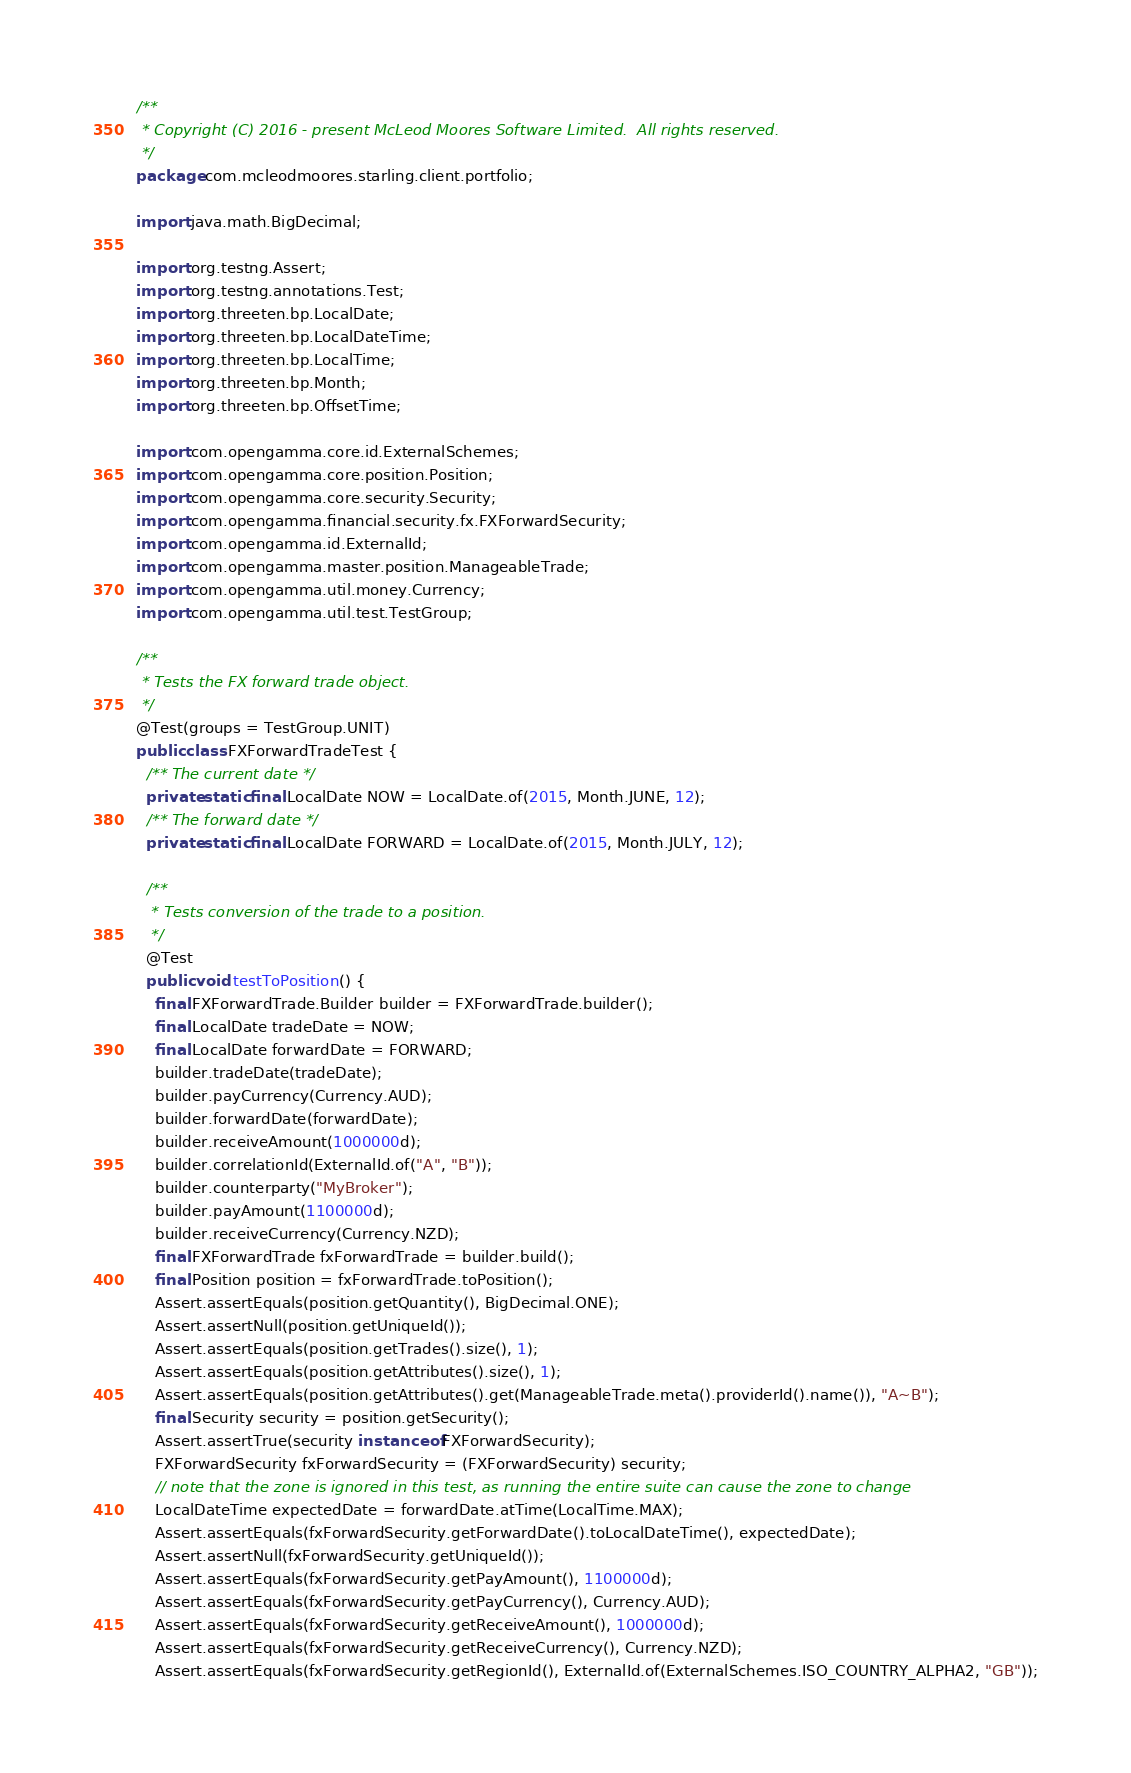<code> <loc_0><loc_0><loc_500><loc_500><_Java_>/**
 * Copyright (C) 2016 - present McLeod Moores Software Limited.  All rights reserved.
 */
package com.mcleodmoores.starling.client.portfolio;

import java.math.BigDecimal;

import org.testng.Assert;
import org.testng.annotations.Test;
import org.threeten.bp.LocalDate;
import org.threeten.bp.LocalDateTime;
import org.threeten.bp.LocalTime;
import org.threeten.bp.Month;
import org.threeten.bp.OffsetTime;

import com.opengamma.core.id.ExternalSchemes;
import com.opengamma.core.position.Position;
import com.opengamma.core.security.Security;
import com.opengamma.financial.security.fx.FXForwardSecurity;
import com.opengamma.id.ExternalId;
import com.opengamma.master.position.ManageableTrade;
import com.opengamma.util.money.Currency;
import com.opengamma.util.test.TestGroup;

/**
 * Tests the FX forward trade object.
 */
@Test(groups = TestGroup.UNIT)
public class FXForwardTradeTest {
  /** The current date */
  private static final LocalDate NOW = LocalDate.of(2015, Month.JUNE, 12);
  /** The forward date */
  private static final LocalDate FORWARD = LocalDate.of(2015, Month.JULY, 12);

  /**
   * Tests conversion of the trade to a position.
   */
  @Test
  public void testToPosition() {
    final FXForwardTrade.Builder builder = FXForwardTrade.builder();
    final LocalDate tradeDate = NOW;
    final LocalDate forwardDate = FORWARD;
    builder.tradeDate(tradeDate);
    builder.payCurrency(Currency.AUD);
    builder.forwardDate(forwardDate);
    builder.receiveAmount(1000000d);
    builder.correlationId(ExternalId.of("A", "B"));
    builder.counterparty("MyBroker");
    builder.payAmount(1100000d);
    builder.receiveCurrency(Currency.NZD);
    final FXForwardTrade fxForwardTrade = builder.build();
    final Position position = fxForwardTrade.toPosition();
    Assert.assertEquals(position.getQuantity(), BigDecimal.ONE);
    Assert.assertNull(position.getUniqueId());
    Assert.assertEquals(position.getTrades().size(), 1);
    Assert.assertEquals(position.getAttributes().size(), 1);
    Assert.assertEquals(position.getAttributes().get(ManageableTrade.meta().providerId().name()), "A~B");
    final Security security = position.getSecurity();
    Assert.assertTrue(security instanceof FXForwardSecurity);
    FXForwardSecurity fxForwardSecurity = (FXForwardSecurity) security;
    // note that the zone is ignored in this test, as running the entire suite can cause the zone to change
    LocalDateTime expectedDate = forwardDate.atTime(LocalTime.MAX);
    Assert.assertEquals(fxForwardSecurity.getForwardDate().toLocalDateTime(), expectedDate);
    Assert.assertNull(fxForwardSecurity.getUniqueId());
    Assert.assertEquals(fxForwardSecurity.getPayAmount(), 1100000d);
    Assert.assertEquals(fxForwardSecurity.getPayCurrency(), Currency.AUD);
    Assert.assertEquals(fxForwardSecurity.getReceiveAmount(), 1000000d);
    Assert.assertEquals(fxForwardSecurity.getReceiveCurrency(), Currency.NZD);
    Assert.assertEquals(fxForwardSecurity.getRegionId(), ExternalId.of(ExternalSchemes.ISO_COUNTRY_ALPHA2, "GB"));</code> 